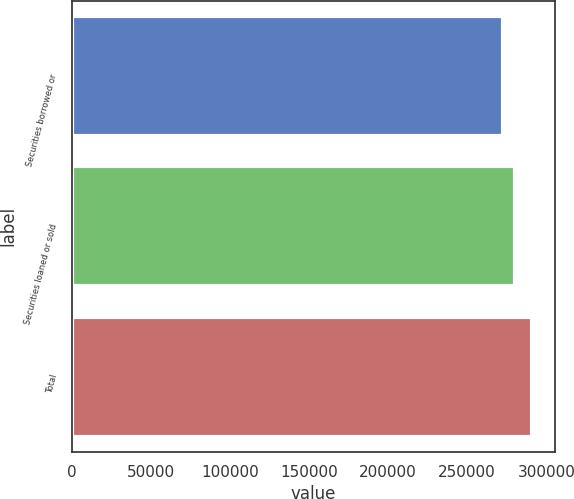Convert chart. <chart><loc_0><loc_0><loc_500><loc_500><bar_chart><fcel>Securities borrowed or<fcel>Securities loaned or sold<fcel>Total<nl><fcel>272296<fcel>279888<fcel>290759<nl></chart> 